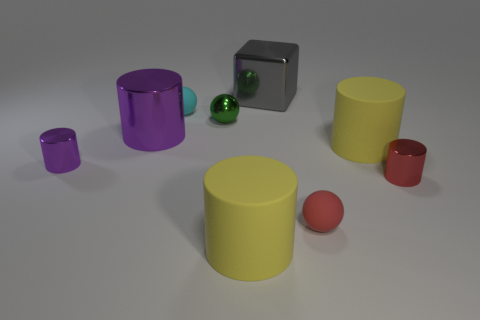The metallic thing that is the same color as the large shiny cylinder is what size?
Give a very brief answer. Small. There is a small red thing in front of the tiny red metal cylinder; what is its shape?
Provide a short and direct response. Sphere. What is the color of the thing in front of the tiny rubber ball that is in front of the large metallic thing that is on the left side of the big gray shiny object?
Your answer should be very brief. Yellow. Does the cube have the same material as the small red sphere?
Your response must be concise. No. What number of yellow objects are small metallic cylinders or big shiny cubes?
Your response must be concise. 0. There is a metallic cube; what number of red rubber balls are behind it?
Offer a terse response. 0. Are there more large purple shiny cylinders than big cyan rubber blocks?
Your response must be concise. Yes. There is a large yellow matte object in front of the red ball that is in front of the small red metal cylinder; what is its shape?
Ensure brevity in your answer.  Cylinder. Does the big shiny block have the same color as the tiny shiny ball?
Your answer should be compact. No. Are there more tiny cyan things that are on the left side of the tiny cyan ball than small purple cylinders?
Provide a succinct answer. No. 